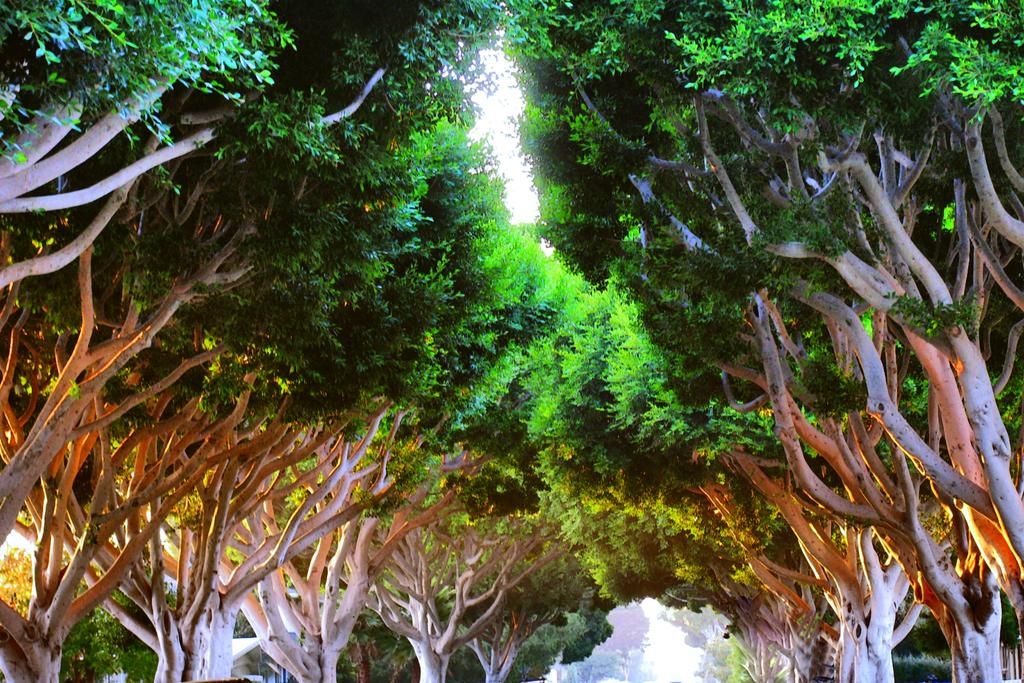What type of vegetation can be seen in the image? There are trees in the image. What is visible at the top of the image? The sky is visible at the top of the image. How many worms can be seen crawling on the trees during the rainstorm in the image? There are no worms or rainstorm present in the image; it features trees and a visible sky. 